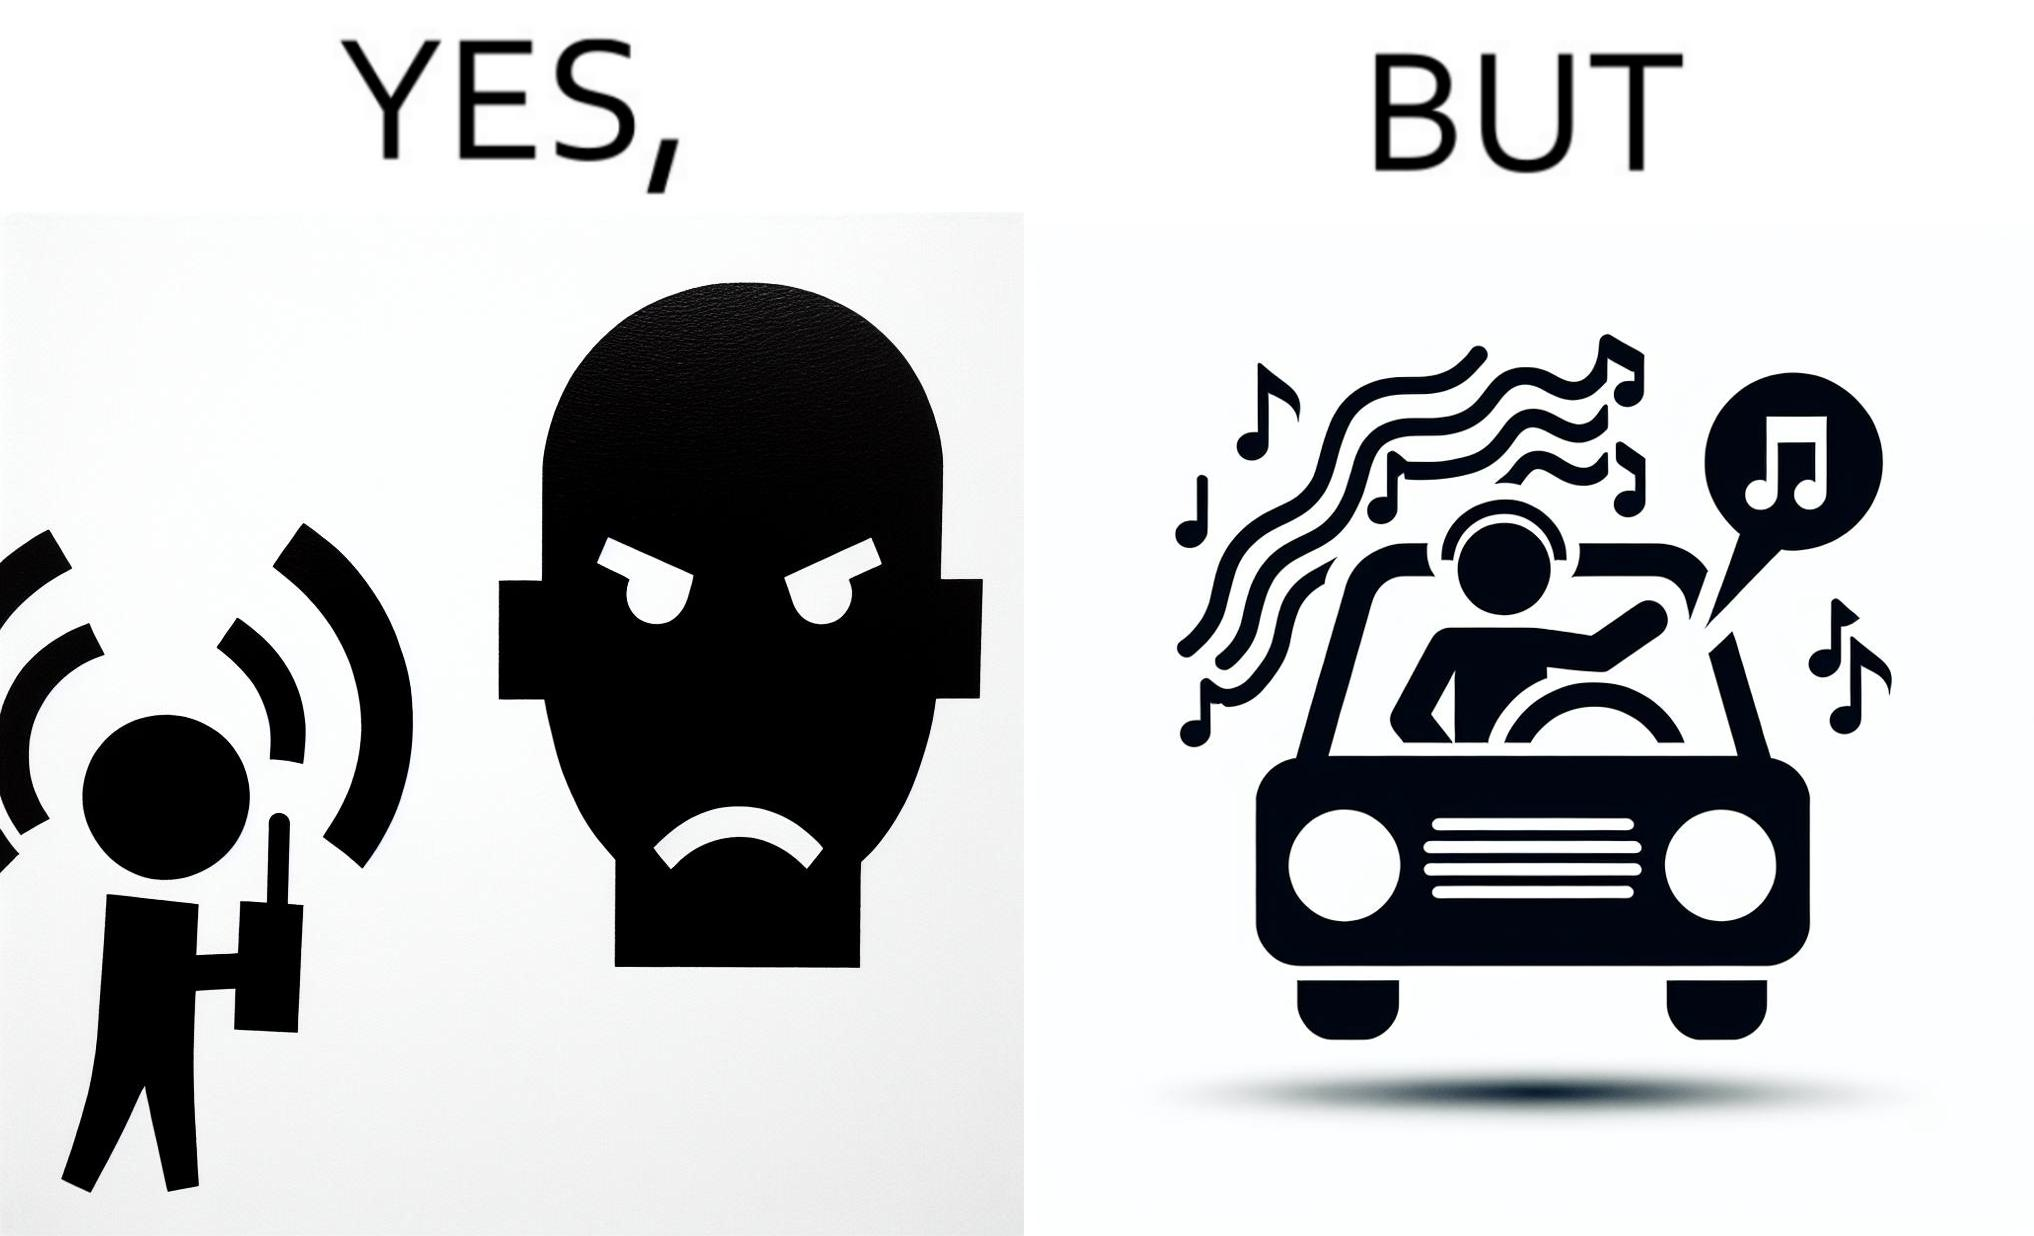What makes this image funny or satirical? The image is funny because while the man does not like the boy playing music loudly on his phone, the man himself is okay with doing the same thing with his car and playing loud music in the car with the sound coming out of the car. 